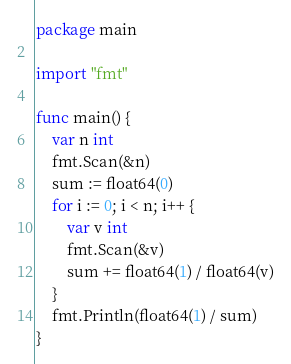<code> <loc_0><loc_0><loc_500><loc_500><_Go_>package main

import "fmt"

func main() {
	var n int
	fmt.Scan(&n)
	sum := float64(0)
	for i := 0; i < n; i++ {
		var v int
		fmt.Scan(&v)
		sum += float64(1) / float64(v)
	}
	fmt.Println(float64(1) / sum)
}
</code> 